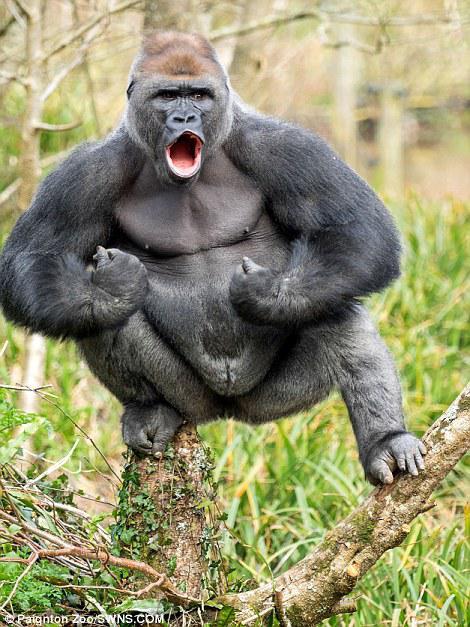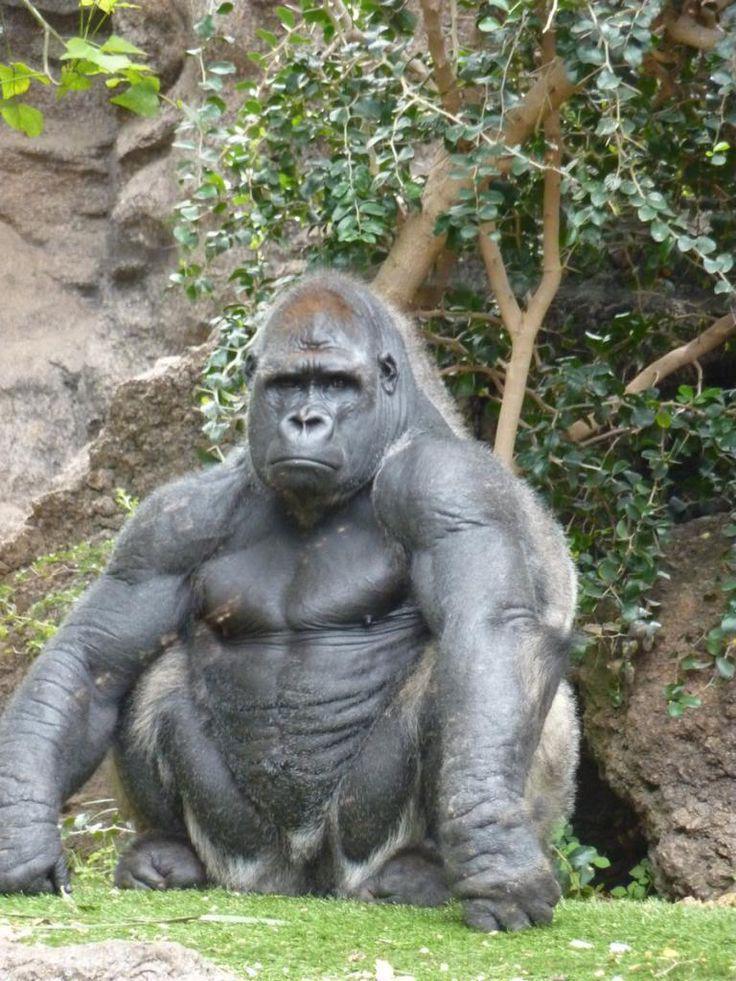The first image is the image on the left, the second image is the image on the right. For the images displayed, is the sentence "Two gorillas are bent forward, standing on all four feet." factually correct? Answer yes or no. No. The first image is the image on the left, the second image is the image on the right. Analyze the images presented: Is the assertion "All images show a gorilla standing on its legs and hands." valid? Answer yes or no. No. 